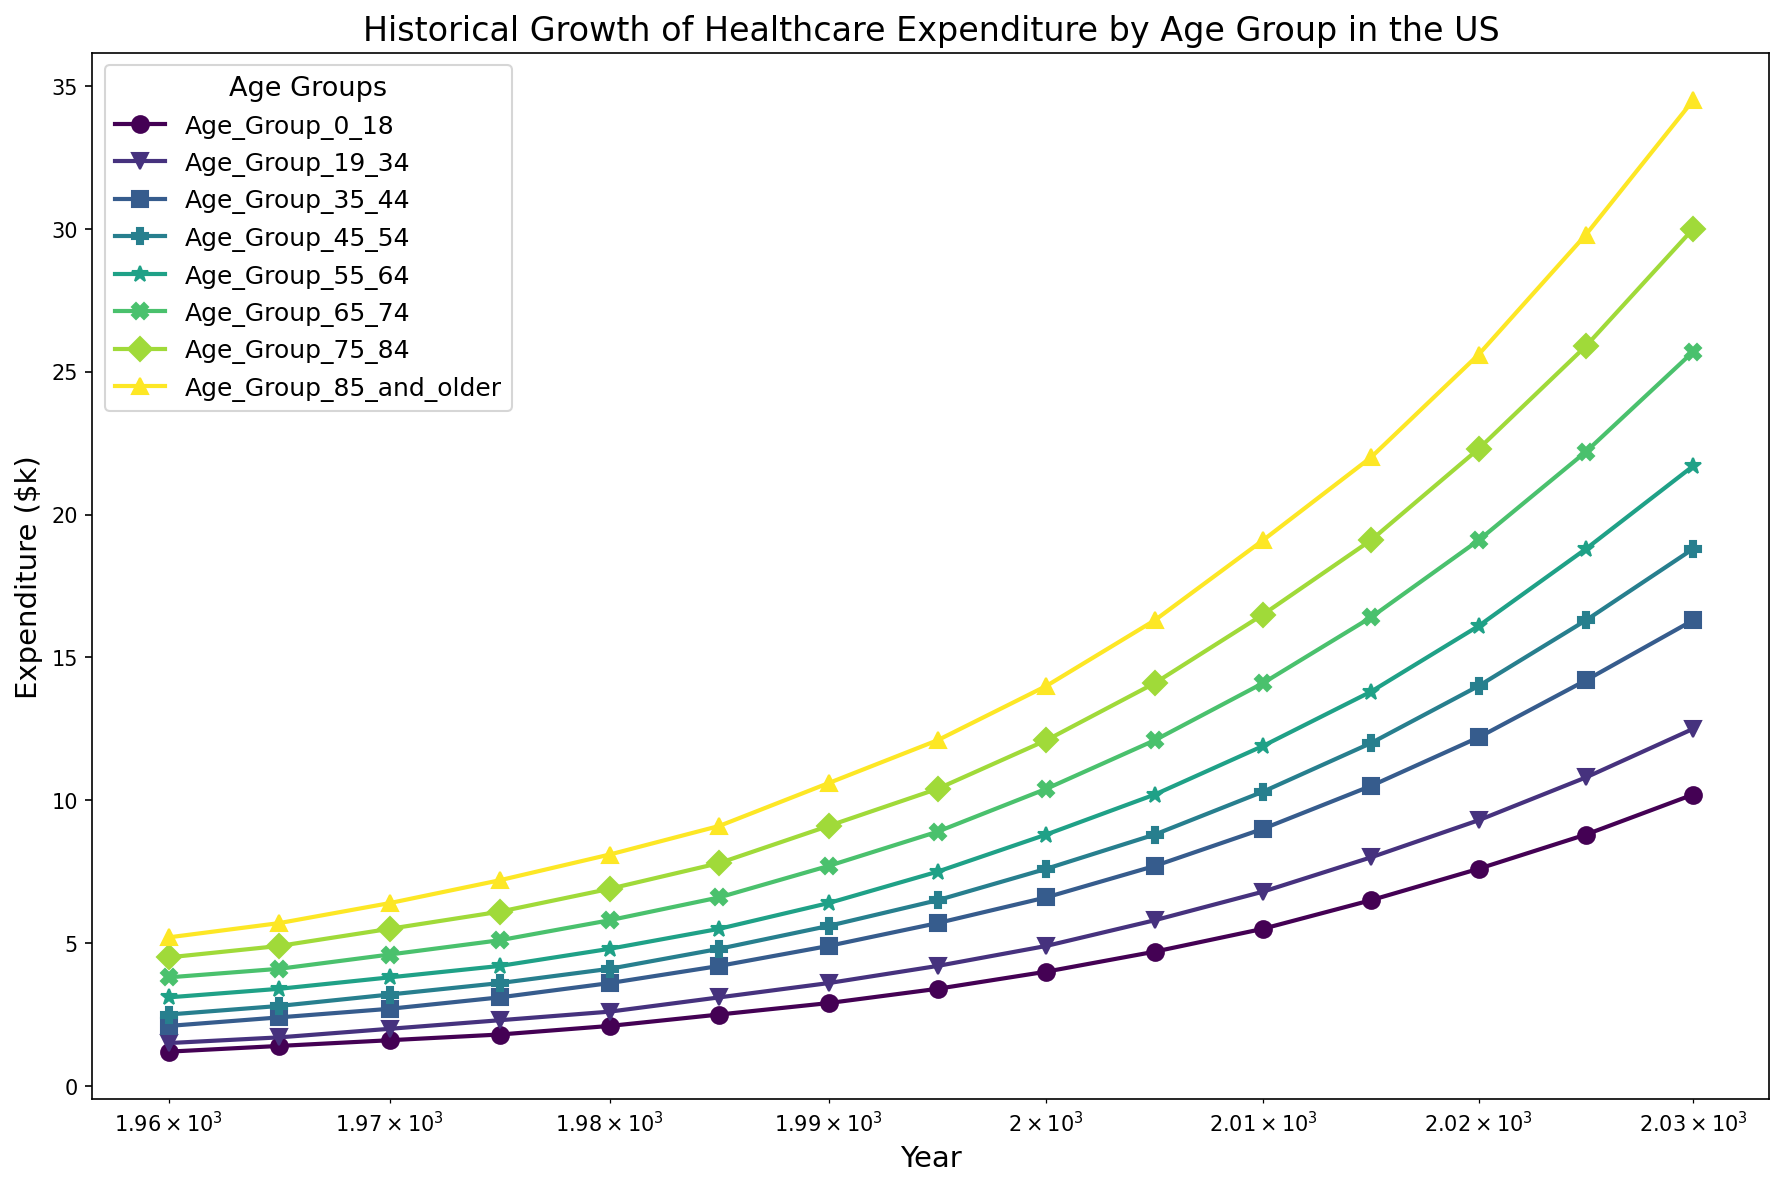What age group had the highest healthcare expenditure in 1970? Look at the data points corresponding to the year 1970 and compare the values for each age group. The highest number is 6.4 which corresponds to the age group 85 and older.
Answer: 85 and older Which age group experienced the largest increase in healthcare expenditure from 2000 to 2030? Subtract the 2000 expenditure values from the 2030 expenditure values for each age group, then find the largest difference. The largest increase is (34.5 - 14.0) = 20.5 for the age group 85 and older.
Answer: 85 and older What was the healthcare expenditure for the 45-54 age group in 2010? Locate the value for the 45-54 age group corresponding to the year 2010. The value is 10.3.
Answer: 10.3 How did the healthcare expenditure for the 0-18 age group in 1980 compare to that in 2020? Compare the values of healthcare expenditure for the 0-18 age group between the years 1980 and 2020. The values are 2.1 in 1980 and 7.6 in 2020.
Answer: Increased Which age group had the lowest healthcare expenditure in 1985? Look at the data points corresponding to the year 1985 and find the smallest value among the age groups. The smallest value is 2.5 for the 0-18 age group.
Answer: 0-18 What is the average healthcare expenditure for the 55-64 age group across all years presented? Sum all the expenditure values for the 55-64 age group and divide by the number of years. The sum is (3.1+3.4+3.8+4.2+4.8+5.5+6.4+7.5+8.8+10.2+11.9+13.8+16.1+18.8+21.7) = 140.2, dividing by 15 years gives an average of approximately 9.35.
Answer: 9.35 Between 2020 and 2025, which age group saw the smallest increase in healthcare expenditure? Subtract the 2020 expenditure values from the 2025 expenditure values for each age group and find the smallest difference. The smallest increase is (25.6 - 22.3) = 3.3 for the 75-84 age group.
Answer: 75-84 What was the healthcare expenditure for the age group 19-34 in 1990? Locate the value for the 19-34 age group corresponding to the year 1990. The value is 3.6.
Answer: 3.6 Which age group is represented by the green color in the plot? Refer to the code where colors were assigned using the 'viridis' color map and note that it spans from purple to green to yellow. Note that greens are generally near the midpoint of the color scale, indicating middle aged groups. Upon checking the number of age groups and colors, the fourth color after 0-18, 19-34, and 35-44, which is green, corresponds to the 45-54 age group.
Answer: 45-54 